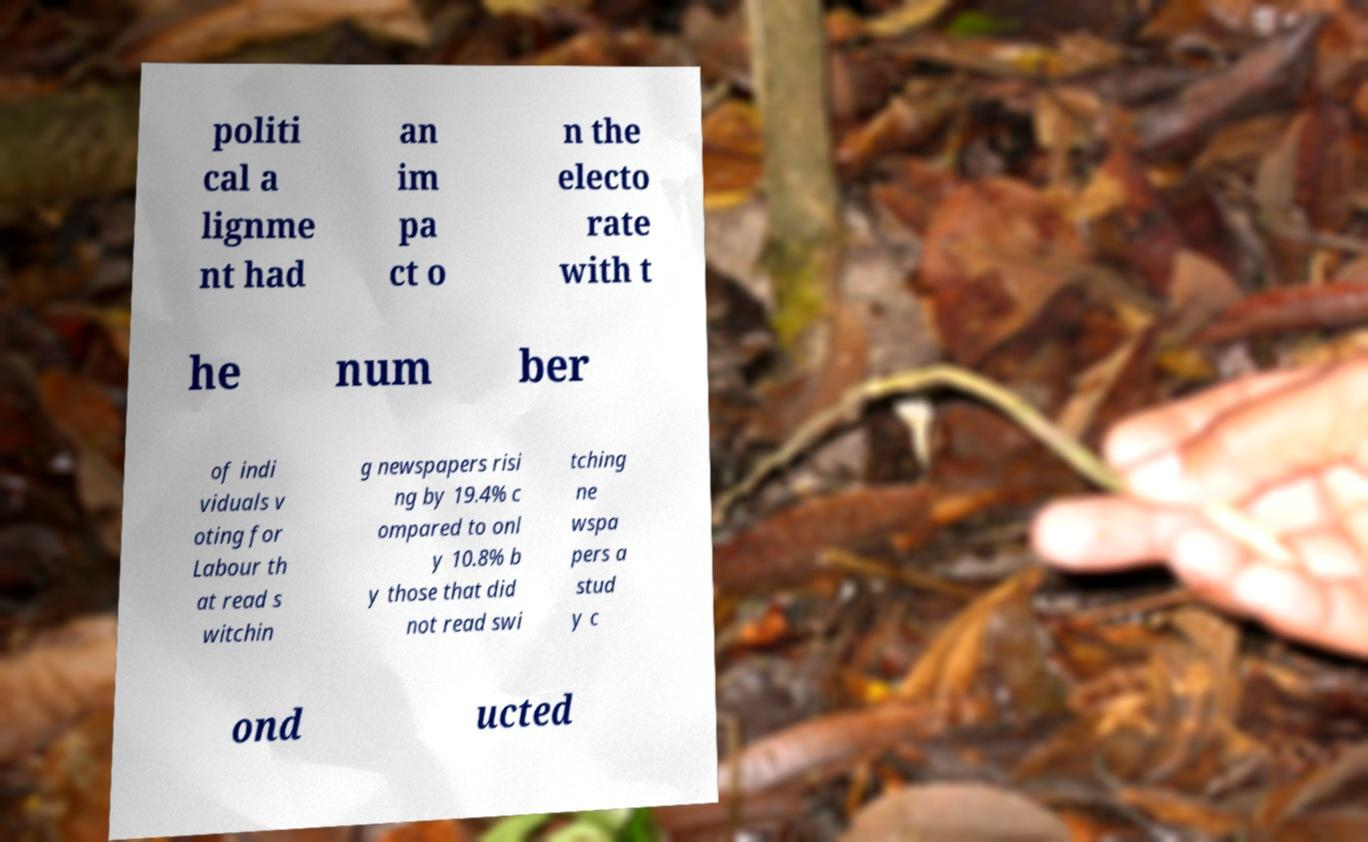Please read and relay the text visible in this image. What does it say? politi cal a lignme nt had an im pa ct o n the electo rate with t he num ber of indi viduals v oting for Labour th at read s witchin g newspapers risi ng by 19.4% c ompared to onl y 10.8% b y those that did not read swi tching ne wspa pers a stud y c ond ucted 